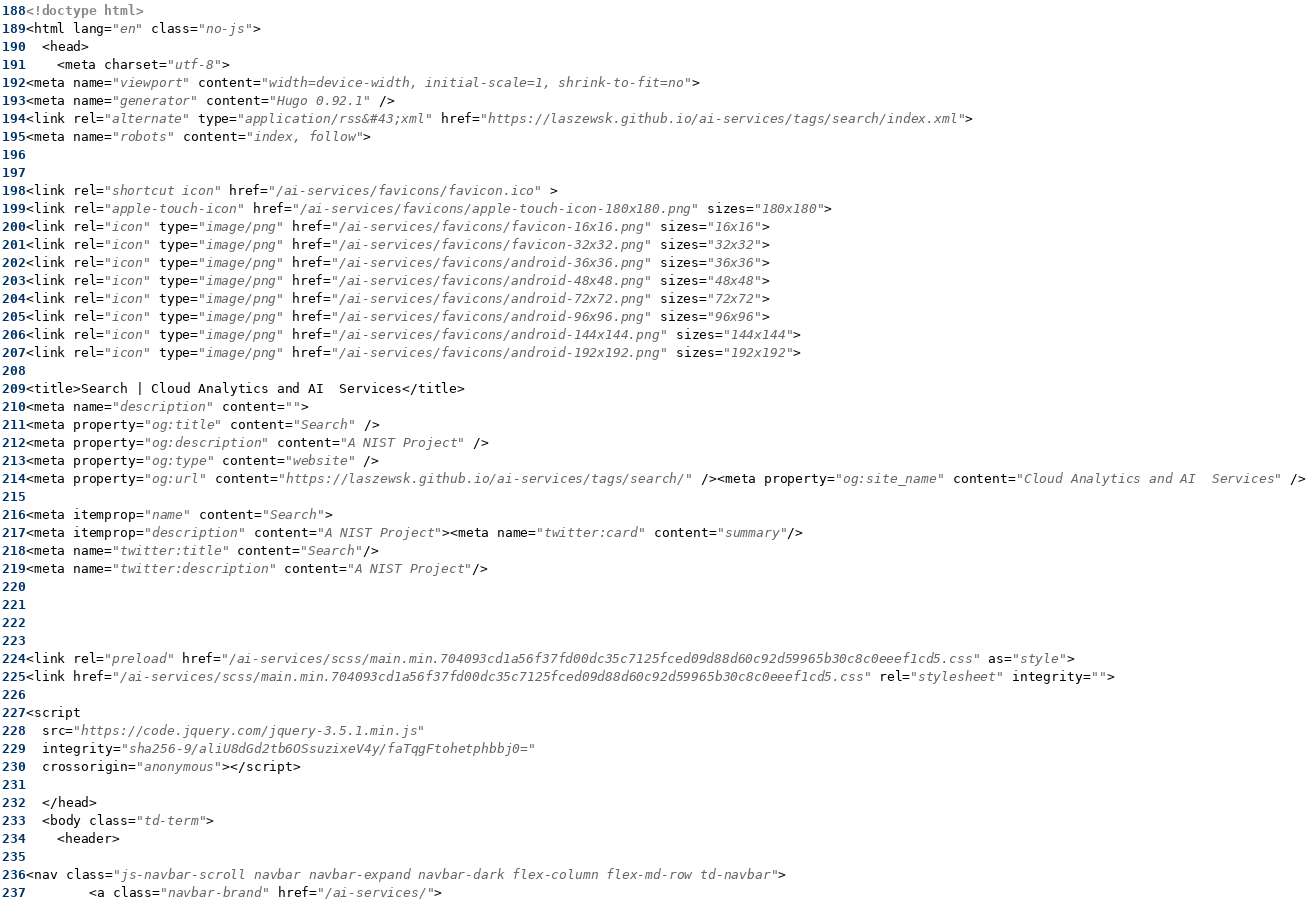<code> <loc_0><loc_0><loc_500><loc_500><_HTML_><!doctype html>
<html lang="en" class="no-js">
  <head>
    <meta charset="utf-8">
<meta name="viewport" content="width=device-width, initial-scale=1, shrink-to-fit=no">
<meta name="generator" content="Hugo 0.92.1" />
<link rel="alternate" type="application/rss&#43;xml" href="https://laszewsk.github.io/ai-services/tags/search/index.xml">
<meta name="robots" content="index, follow">


<link rel="shortcut icon" href="/ai-services/favicons/favicon.ico" >
<link rel="apple-touch-icon" href="/ai-services/favicons/apple-touch-icon-180x180.png" sizes="180x180">
<link rel="icon" type="image/png" href="/ai-services/favicons/favicon-16x16.png" sizes="16x16">
<link rel="icon" type="image/png" href="/ai-services/favicons/favicon-32x32.png" sizes="32x32">
<link rel="icon" type="image/png" href="/ai-services/favicons/android-36x36.png" sizes="36x36">
<link rel="icon" type="image/png" href="/ai-services/favicons/android-48x48.png" sizes="48x48">
<link rel="icon" type="image/png" href="/ai-services/favicons/android-72x72.png" sizes="72x72">
<link rel="icon" type="image/png" href="/ai-services/favicons/android-96x96.png" sizes="96x96">
<link rel="icon" type="image/png" href="/ai-services/favicons/android-144x144.png" sizes="144x144">
<link rel="icon" type="image/png" href="/ai-services/favicons/android-192x192.png" sizes="192x192">

<title>Search | Cloud Analytics and AI  Services</title>
<meta name="description" content="">
<meta property="og:title" content="Search" />
<meta property="og:description" content="A NIST Project" />
<meta property="og:type" content="website" />
<meta property="og:url" content="https://laszewsk.github.io/ai-services/tags/search/" /><meta property="og:site_name" content="Cloud Analytics and AI  Services" />

<meta itemprop="name" content="Search">
<meta itemprop="description" content="A NIST Project"><meta name="twitter:card" content="summary"/>
<meta name="twitter:title" content="Search"/>
<meta name="twitter:description" content="A NIST Project"/>




<link rel="preload" href="/ai-services/scss/main.min.704093cd1a56f37fd00dc35c7125fced09d88d60c92d59965b30c8c0eeef1cd5.css" as="style">
<link href="/ai-services/scss/main.min.704093cd1a56f37fd00dc35c7125fced09d88d60c92d59965b30c8c0eeef1cd5.css" rel="stylesheet" integrity="">

<script
  src="https://code.jquery.com/jquery-3.5.1.min.js"
  integrity="sha256-9/aliU8dGd2tb6OSsuzixeV4y/faTqgFtohetphbbj0="
  crossorigin="anonymous"></script>

  </head>
  <body class="td-term">
    <header>
      
<nav class="js-navbar-scroll navbar navbar-expand navbar-dark flex-column flex-md-row td-navbar">
        <a class="navbar-brand" href="/ai-services/"></code> 